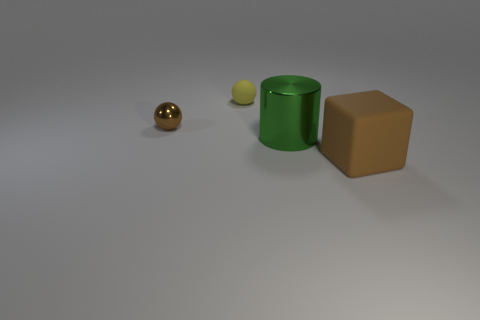What color is the big cylinder? The large cylinder in the image has a vibrant green hue, giving it a fresh and lively appearance against the neutral background. 